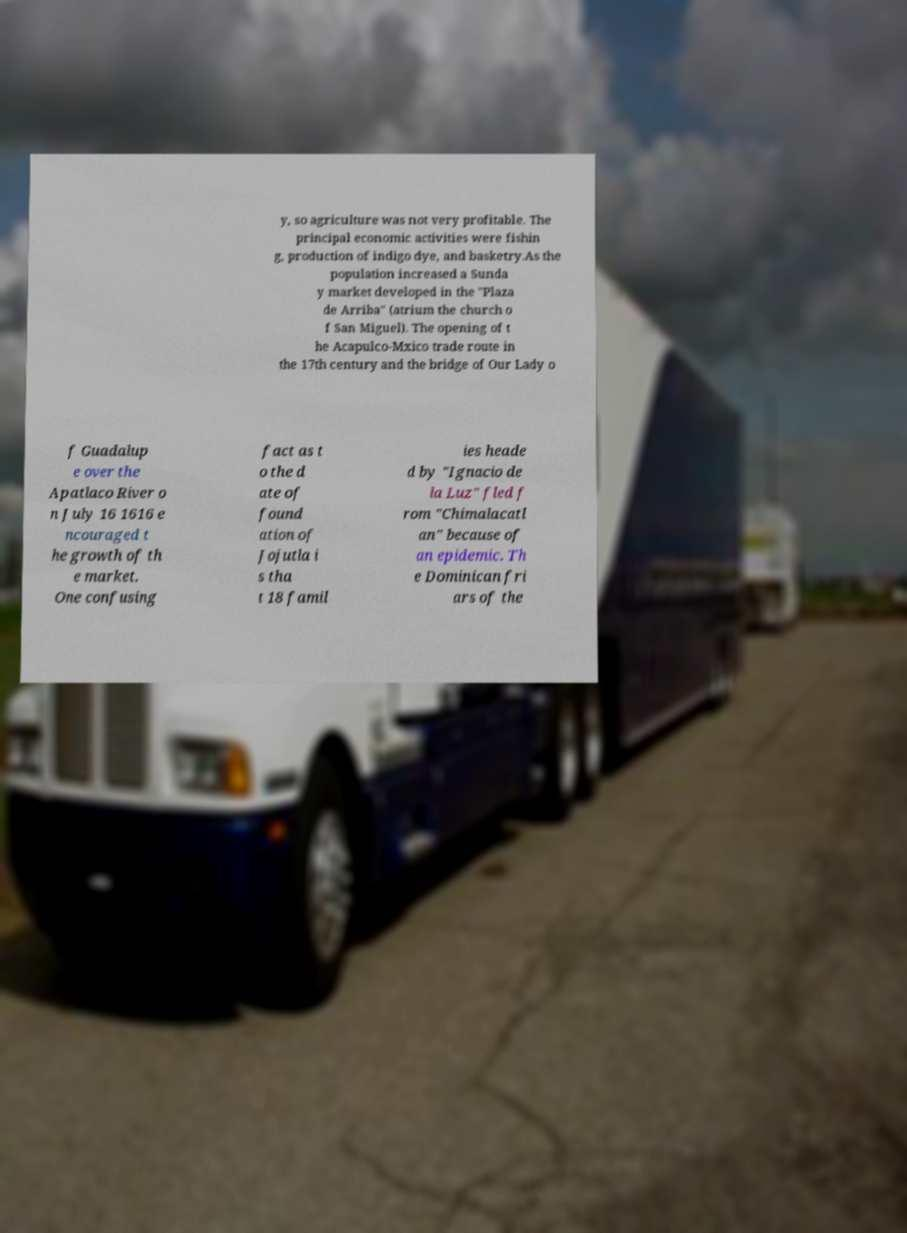Please read and relay the text visible in this image. What does it say? y, so agriculture was not very profitable. The principal economic activities were fishin g, production of indigo dye, and basketry.As the population increased a Sunda y market developed in the "Plaza de Arriba" (atrium the church o f San Miguel). The opening of t he Acapulco-Mxico trade route in the 17th century and the bridge of Our Lady o f Guadalup e over the Apatlaco River o n July 16 1616 e ncouraged t he growth of th e market. One confusing fact as t o the d ate of found ation of Jojutla i s tha t 18 famil ies heade d by "Ignacio de la Luz" fled f rom "Chimalacatl an" because of an epidemic. Th e Dominican fri ars of the 